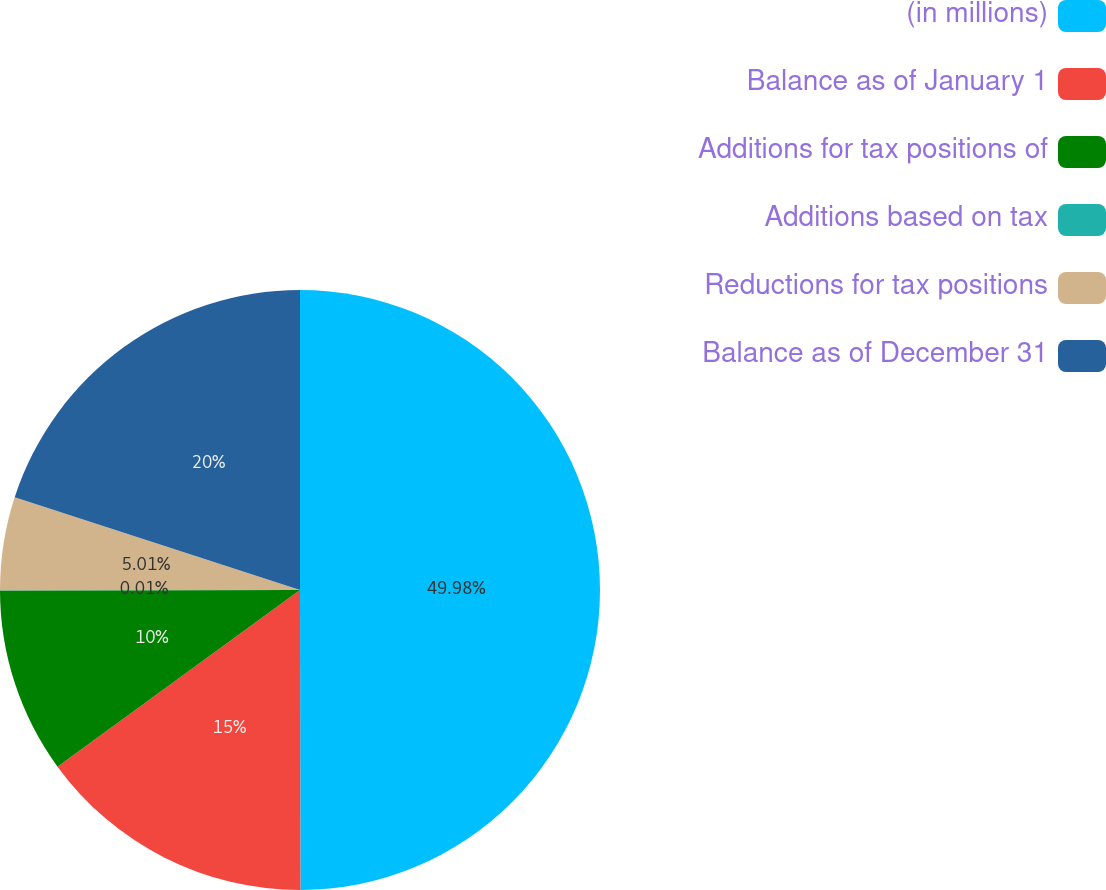Convert chart to OTSL. <chart><loc_0><loc_0><loc_500><loc_500><pie_chart><fcel>(in millions)<fcel>Balance as of January 1<fcel>Additions for tax positions of<fcel>Additions based on tax<fcel>Reductions for tax positions<fcel>Balance as of December 31<nl><fcel>49.98%<fcel>15.0%<fcel>10.0%<fcel>0.01%<fcel>5.01%<fcel>20.0%<nl></chart> 